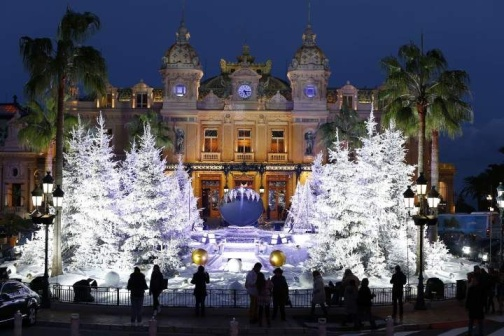Describe the ambiance of the place at night. At night, the place transforms into an enchanting wonderland. The grand building glows warmly with yellow lights, standing out against the deep blue sky. The fountain, dressed in radiant white Christmas lights, adds a layer of festive cheer, while the palm trees seem to sway gently in the cool evening breeze. The presence of people, illuminated by the surrounding lights, brings a sense of liveliness and joy, making the ambiance both magical and inviting. 